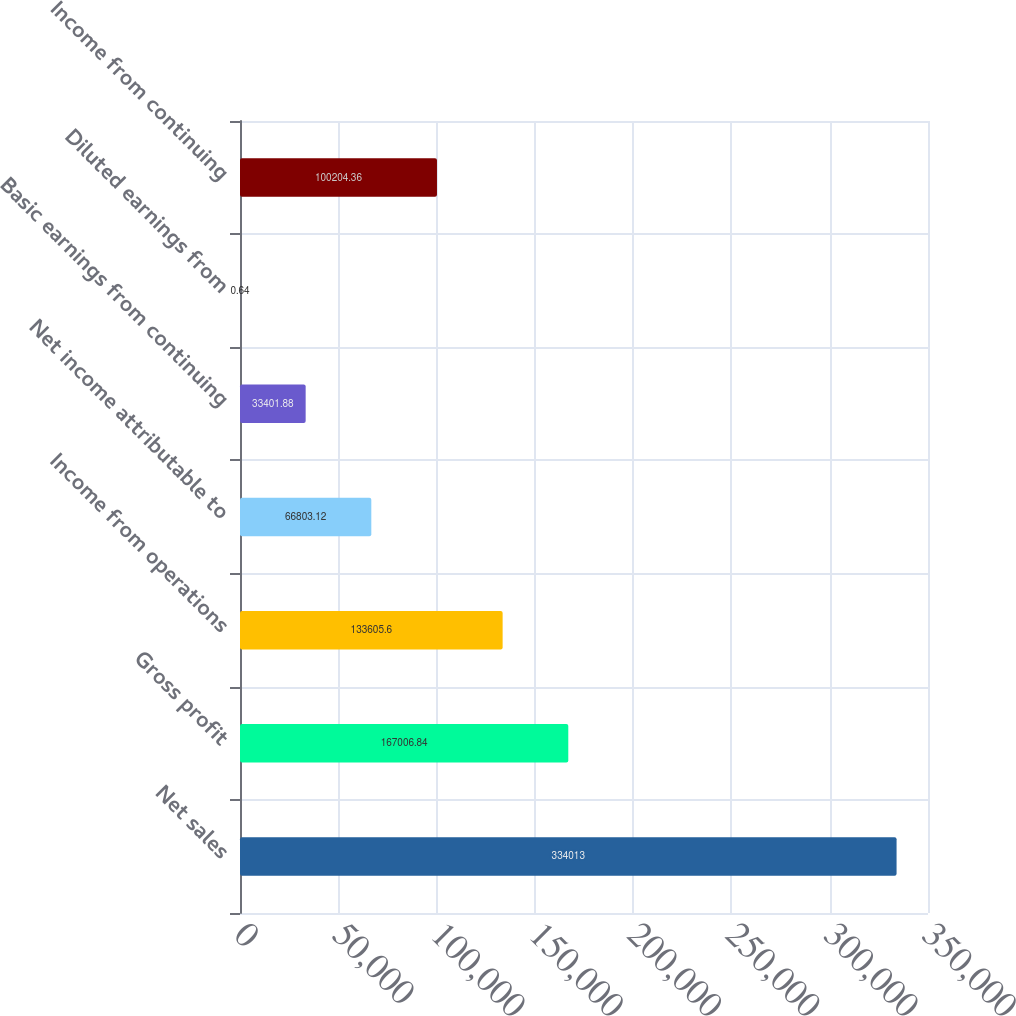<chart> <loc_0><loc_0><loc_500><loc_500><bar_chart><fcel>Net sales<fcel>Gross profit<fcel>Income from operations<fcel>Net income attributable to<fcel>Basic earnings from continuing<fcel>Diluted earnings from<fcel>Income from continuing<nl><fcel>334013<fcel>167007<fcel>133606<fcel>66803.1<fcel>33401.9<fcel>0.64<fcel>100204<nl></chart> 